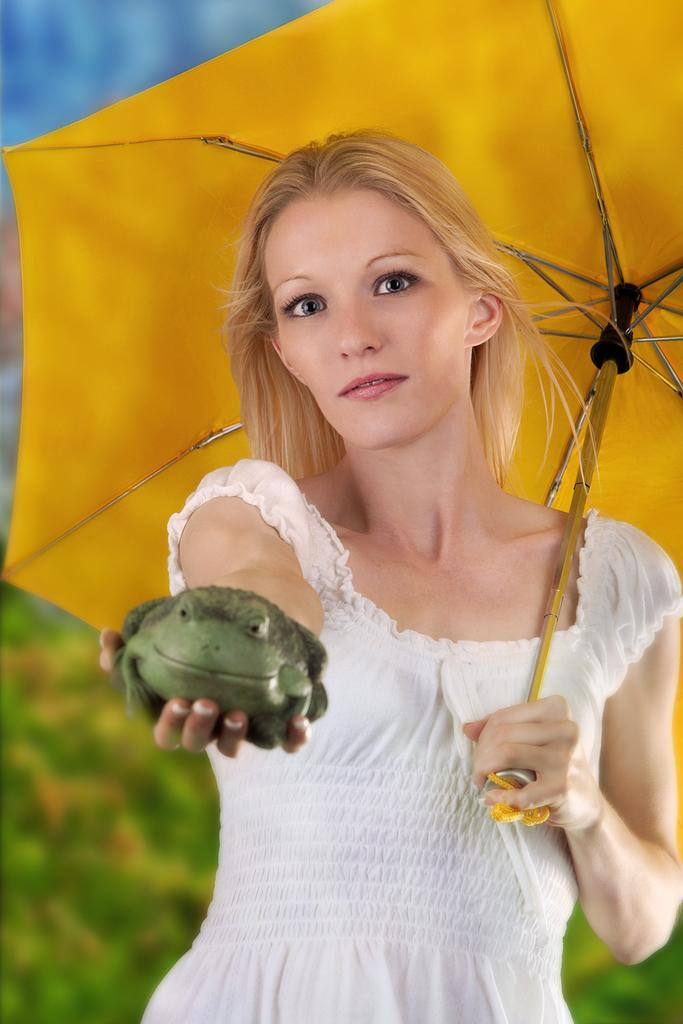Who is the main subject in the image? There is a girl in the image. What is the girl wearing? The girl is wearing clothes. What objects is the girl holding in her hands? The girl is holding an umbrella in one hand and a fork in the other hand. Can you describe the background of the image? The background of the image is blurred. What type of war is depicted in the image? There is no war depicted in the image; it features a girl holding an umbrella and a fork. What stage of development is the girl in the image? The image does not provide information about the girl's stage of development. 